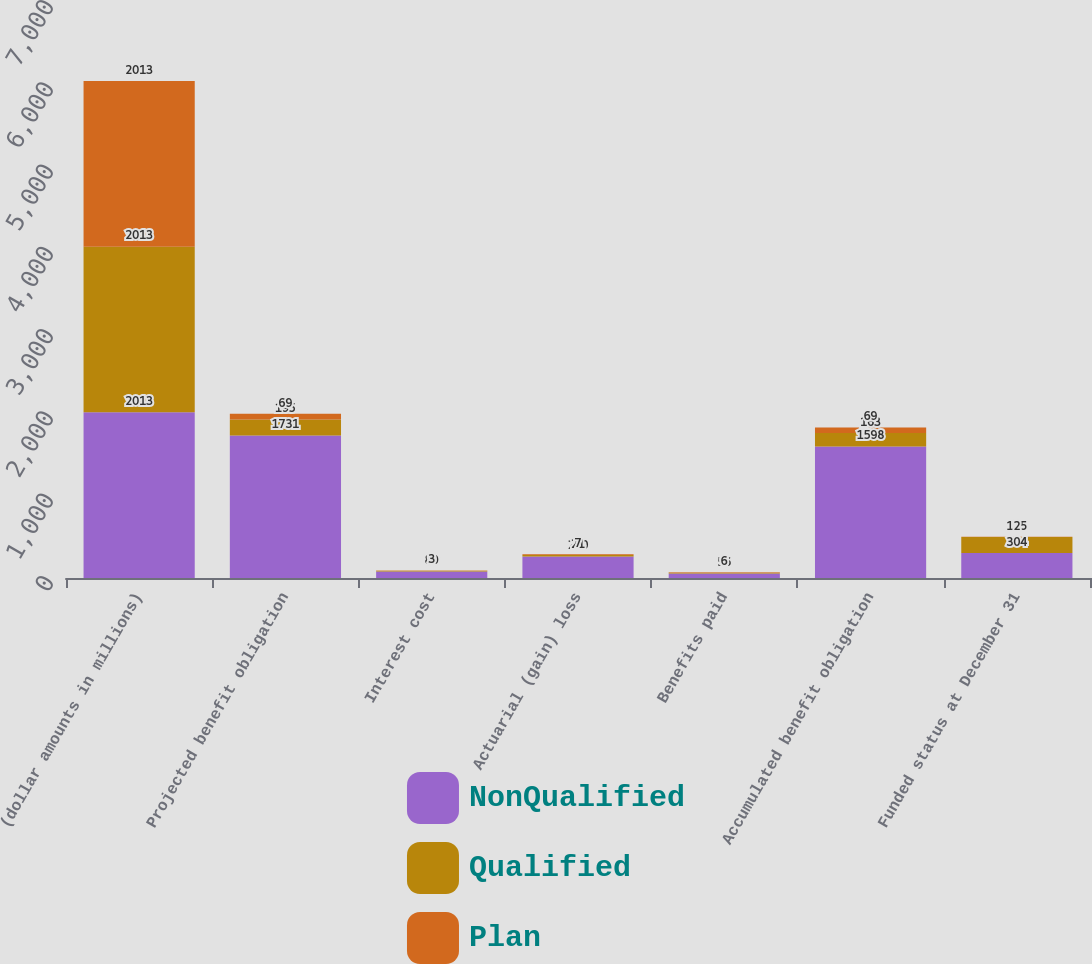<chart> <loc_0><loc_0><loc_500><loc_500><stacked_bar_chart><ecel><fcel>(dollar amounts in millions)<fcel>Projected benefit obligation<fcel>Interest cost<fcel>Actuarial (gain) loss<fcel>Benefits paid<fcel>Accumulated benefit obligation<fcel>Funded status at December 31<nl><fcel>NonQualified<fcel>2013<fcel>1731<fcel>80<fcel>260<fcel>56<fcel>1598<fcel>304<nl><fcel>Qualified<fcel>2013<fcel>195<fcel>9<fcel>21<fcel>9<fcel>163<fcel>195<nl><fcel>Plan<fcel>2013<fcel>69<fcel>3<fcel>7<fcel>6<fcel>69<fcel>2<nl></chart> 